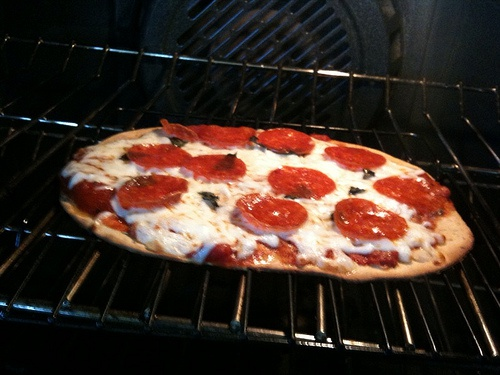Describe the objects in this image and their specific colors. I can see oven in black, brown, beige, and tan tones and pizza in black, brown, beige, and tan tones in this image. 